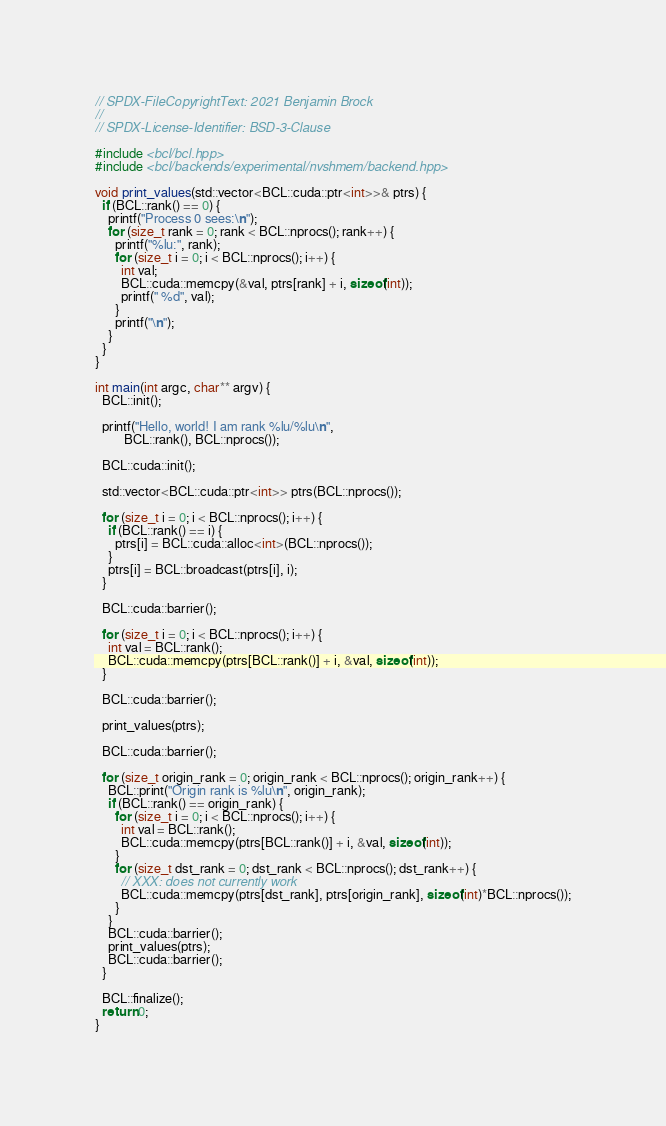Convert code to text. <code><loc_0><loc_0><loc_500><loc_500><_Cuda_>// SPDX-FileCopyrightText: 2021 Benjamin Brock
//
// SPDX-License-Identifier: BSD-3-Clause

#include <bcl/bcl.hpp>
#include <bcl/backends/experimental/nvshmem/backend.hpp>

void print_values(std::vector<BCL::cuda::ptr<int>>& ptrs) {
  if (BCL::rank() == 0) {
    printf("Process 0 sees:\n");
    for (size_t rank = 0; rank < BCL::nprocs(); rank++) {
      printf("%lu:", rank);
      for (size_t i = 0; i < BCL::nprocs(); i++) {
        int val;
        BCL::cuda::memcpy(&val, ptrs[rank] + i, sizeof(int));
        printf(" %d", val);
      }
      printf("\n");
    }
  }
}

int main(int argc, char** argv) {
  BCL::init();

  printf("Hello, world! I am rank %lu/%lu\n",
         BCL::rank(), BCL::nprocs());

  BCL::cuda::init();

  std::vector<BCL::cuda::ptr<int>> ptrs(BCL::nprocs());

  for (size_t i = 0; i < BCL::nprocs(); i++) {
    if (BCL::rank() == i) {
      ptrs[i] = BCL::cuda::alloc<int>(BCL::nprocs());
    }
    ptrs[i] = BCL::broadcast(ptrs[i], i);
  }

  BCL::cuda::barrier();

  for (size_t i = 0; i < BCL::nprocs(); i++) {
    int val = BCL::rank();
    BCL::cuda::memcpy(ptrs[BCL::rank()] + i, &val, sizeof(int));
  }

  BCL::cuda::barrier();

  print_values(ptrs);

  BCL::cuda::barrier();

  for (size_t origin_rank = 0; origin_rank < BCL::nprocs(); origin_rank++) {
    BCL::print("Origin rank is %lu\n", origin_rank);
    if (BCL::rank() == origin_rank) {
      for (size_t i = 0; i < BCL::nprocs(); i++) {
        int val = BCL::rank();
        BCL::cuda::memcpy(ptrs[BCL::rank()] + i, &val, sizeof(int));
      }
      for (size_t dst_rank = 0; dst_rank < BCL::nprocs(); dst_rank++) {
        // XXX: does not currently work
        BCL::cuda::memcpy(ptrs[dst_rank], ptrs[origin_rank], sizeof(int)*BCL::nprocs());
      }
    }
    BCL::cuda::barrier();
    print_values(ptrs);
    BCL::cuda::barrier();
  }

  BCL::finalize();
  return 0;
}
</code> 